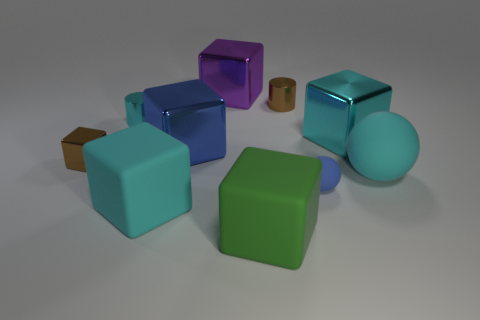Subtract 2 blocks. How many blocks are left? 4 Subtract all cyan metallic blocks. How many blocks are left? 5 Subtract all brown cubes. How many cubes are left? 5 Subtract all yellow blocks. Subtract all gray cylinders. How many blocks are left? 6 Subtract all spheres. How many objects are left? 8 Add 4 tiny purple blocks. How many tiny purple blocks exist? 4 Subtract 1 cyan cylinders. How many objects are left? 9 Subtract all tiny red matte things. Subtract all tiny matte spheres. How many objects are left? 9 Add 6 brown metal cylinders. How many brown metal cylinders are left? 7 